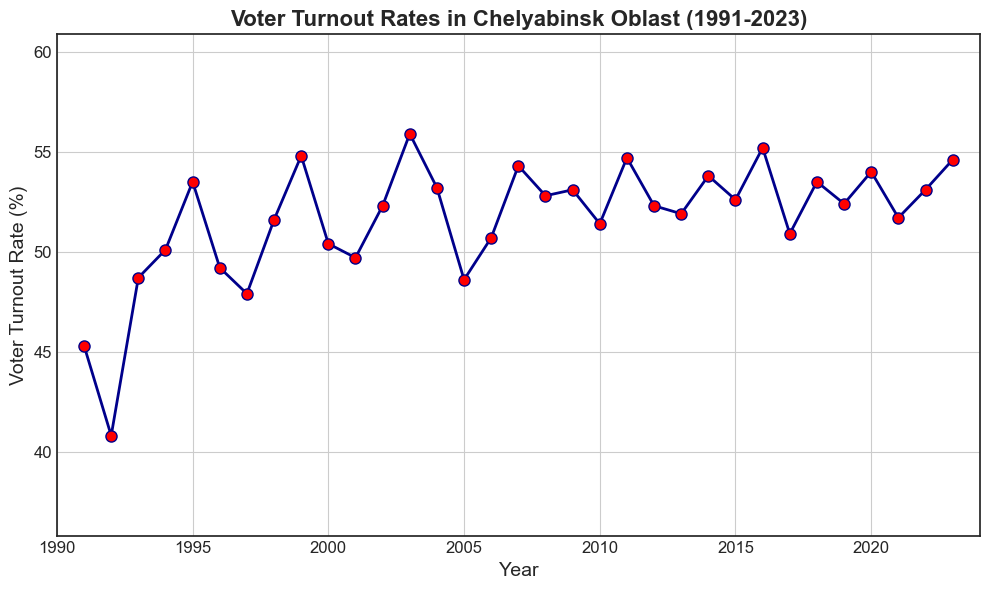What's the highest voter turnout rate in Chelyabinsk Oblast from 1991 to 2023? The highest point on the line chart corresponds to the year 2003, where the voter turnout rate is marked. This is visually the peak of the graph.
Answer: 55.9% Which year had the lowest voter turnout rate? The lowest point on the line chart is 1992, where the voter turnout rate dips to its lowest value.
Answer: 1992 How many years did the voter turnout rate exceed 54%? Locate each point on the chart where the voter turnout rate is above 54%. This occurs in the years 1999, 2003, 2007, 2011, 2016, and 2023. Count these instances.
Answer: 6 Was the voter turnout rate higher in 1997 or 2004? Compare the heights of the points corresponding to the years 1997 and 2004 on the line chart. The rate in 2004 is higher than in 1997.
Answer: 2004 Calculate the average voter turnout rate for the first five years (1991-1995). Sum the voter turnout rates for each year from 1991 to 1995 and then divide by 5. (45.3 + 40.8 + 48.7 + 50.1 + 53.5) / 5 = 238.4 / 5
Answer: 47.68% How did the voter turnout rate change from 2019 to 2020? Compare the voter turnout rates for 2019 and 2020. The chart shows a rise from 52.4% in 2019 to 54.0% in 2020.
Answer: Increased by 1.6% In which decade did the voter turnout rate seem most consistent? Compare the consistency of voter turnout rate trends in the 1990s, 2000s, and 2010s by observing the variability of points within each period. The 2010s have smaller fluctuations compared to other decades.
Answer: 2010s Which year showed the greatest increase in voter turnout rate compared to the previous year? Calculate the year-over-year change in voter turnout rate for each consecutive year and find the maximum increase. The largest increase appears from 1994 (50.1%) to 1995 (53.5%).
Answer: 1995 (3.4% increase) Is there a noticeable trend in voter turnout rates by decade? Observe overall patterns in the data points across each decade: 90s, 2000s, 2010s, and early 2020s, noting any upward or downward trends. There is a general trend of fluctuations with periodic peaks every few years.
Answer: Fluctuating trend What is the difference in voter turnout rates between 2003 and 2005? Subtract the voter turnout rate in 2005 from that in 2003: 55.9% - 48.6% = 7.3%.
Answer: 7.3% 